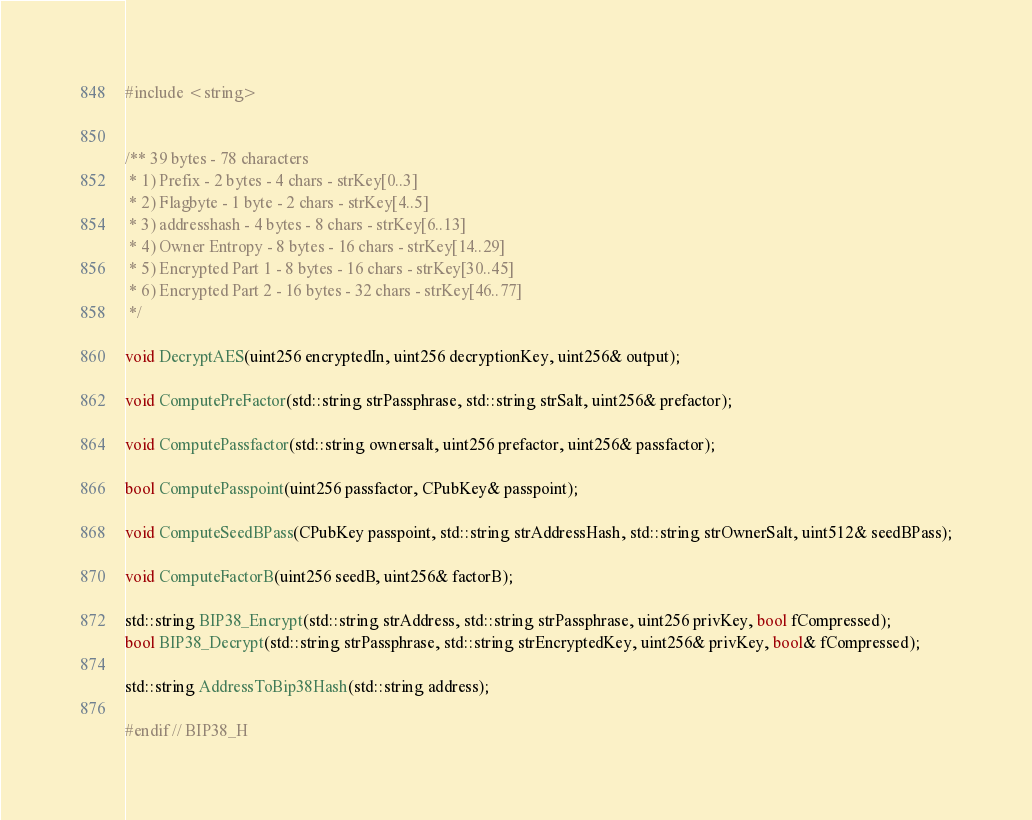<code> <loc_0><loc_0><loc_500><loc_500><_C_>
#include <string>


/** 39 bytes - 78 characters
 * 1) Prefix - 2 bytes - 4 chars - strKey[0..3]
 * 2) Flagbyte - 1 byte - 2 chars - strKey[4..5]
 * 3) addresshash - 4 bytes - 8 chars - strKey[6..13]
 * 4) Owner Entropy - 8 bytes - 16 chars - strKey[14..29]
 * 5) Encrypted Part 1 - 8 bytes - 16 chars - strKey[30..45]
 * 6) Encrypted Part 2 - 16 bytes - 32 chars - strKey[46..77]
 */

void DecryptAES(uint256 encryptedIn, uint256 decryptionKey, uint256& output);

void ComputePreFactor(std::string strPassphrase, std::string strSalt, uint256& prefactor);

void ComputePassfactor(std::string ownersalt, uint256 prefactor, uint256& passfactor);

bool ComputePasspoint(uint256 passfactor, CPubKey& passpoint);

void ComputeSeedBPass(CPubKey passpoint, std::string strAddressHash, std::string strOwnerSalt, uint512& seedBPass);

void ComputeFactorB(uint256 seedB, uint256& factorB);

std::string BIP38_Encrypt(std::string strAddress, std::string strPassphrase, uint256 privKey, bool fCompressed);
bool BIP38_Decrypt(std::string strPassphrase, std::string strEncryptedKey, uint256& privKey, bool& fCompressed);

std::string AddressToBip38Hash(std::string address);

#endif // BIP38_H
</code> 